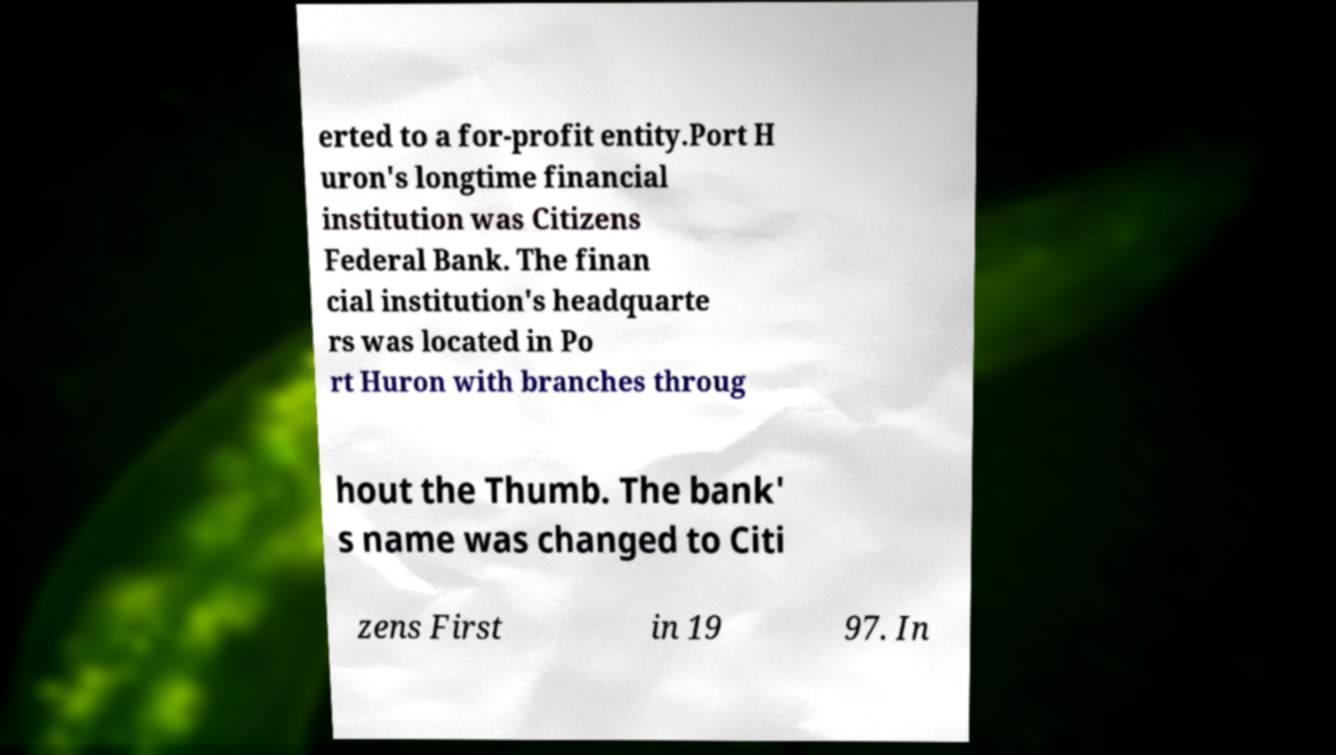What messages or text are displayed in this image? I need them in a readable, typed format. erted to a for-profit entity.Port H uron's longtime financial institution was Citizens Federal Bank. The finan cial institution's headquarte rs was located in Po rt Huron with branches throug hout the Thumb. The bank' s name was changed to Citi zens First in 19 97. In 